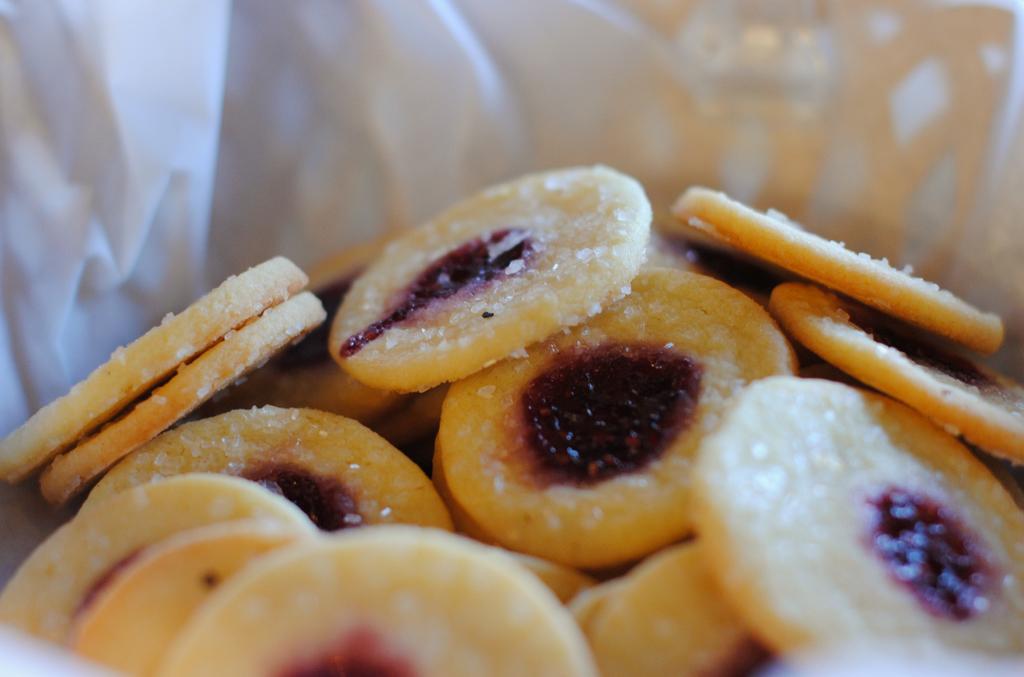How would you summarize this image in a sentence or two? In the center of the image we can see cookies placed in the bowl. 